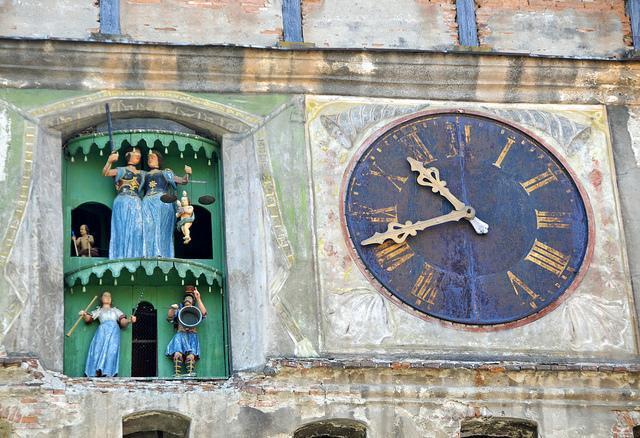How many people are visible?
Give a very brief answer. 2. How many airplanes are flying to the left of the person?
Give a very brief answer. 0. 